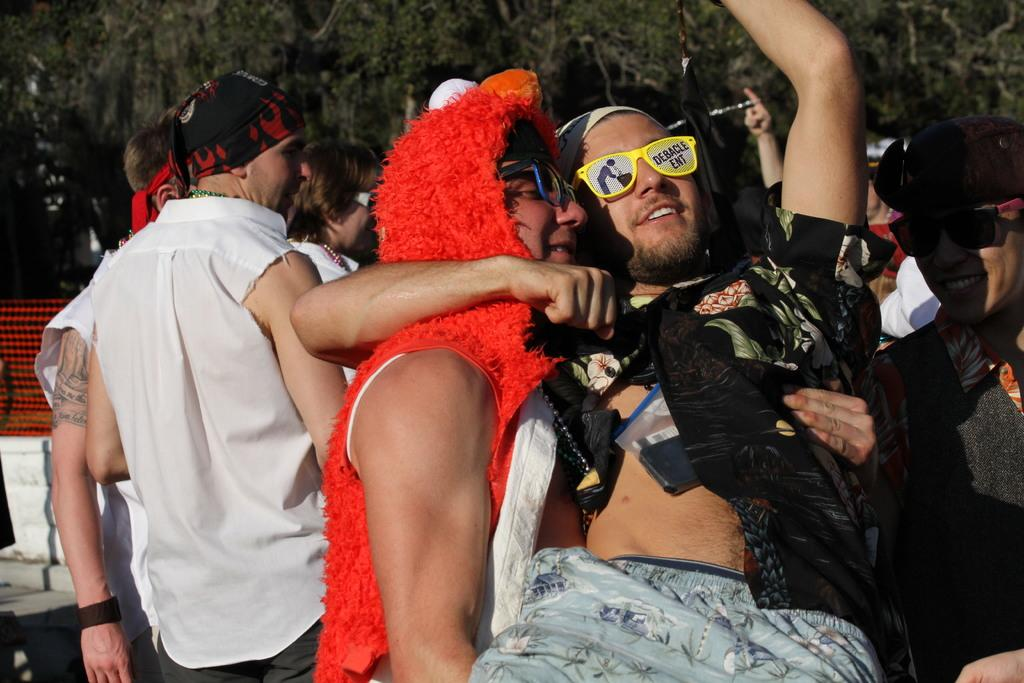What is happening in the image? There are people standing in the image. What are the people wearing? The people are wearing costumes. What can be seen in the background of the image? There are trees visible in the background of the image. What type of feast is being prepared by the grandmother in the image? There is no grandmother or feast present in the image; it only shows people wearing costumes. 